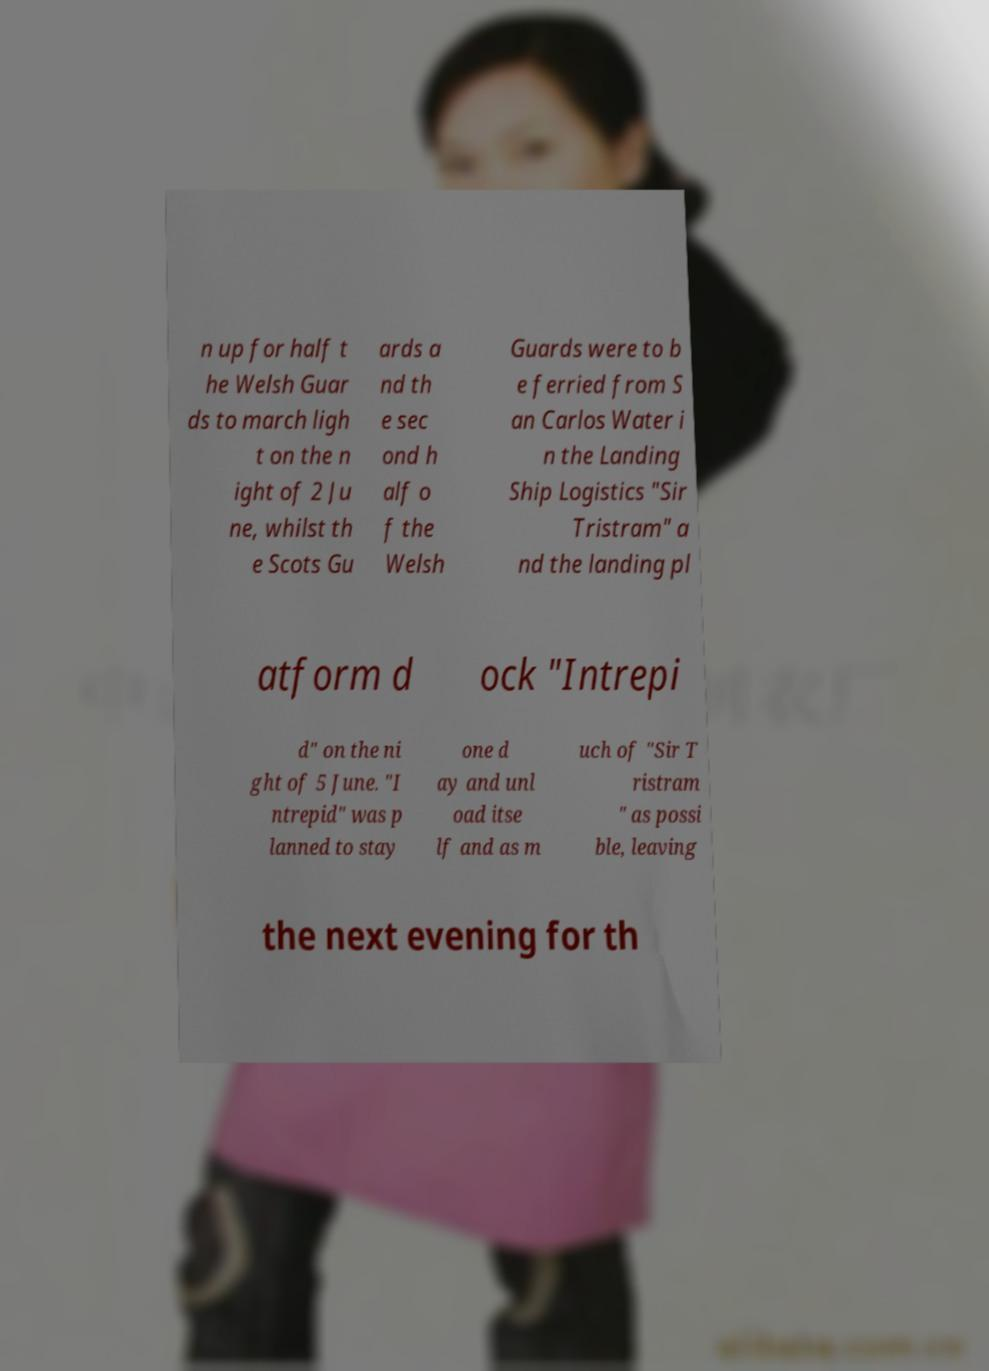Please identify and transcribe the text found in this image. n up for half t he Welsh Guar ds to march ligh t on the n ight of 2 Ju ne, whilst th e Scots Gu ards a nd th e sec ond h alf o f the Welsh Guards were to b e ferried from S an Carlos Water i n the Landing Ship Logistics "Sir Tristram" a nd the landing pl atform d ock "Intrepi d" on the ni ght of 5 June. "I ntrepid" was p lanned to stay one d ay and unl oad itse lf and as m uch of "Sir T ristram " as possi ble, leaving the next evening for th 